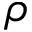<formula> <loc_0><loc_0><loc_500><loc_500>\rho</formula> 